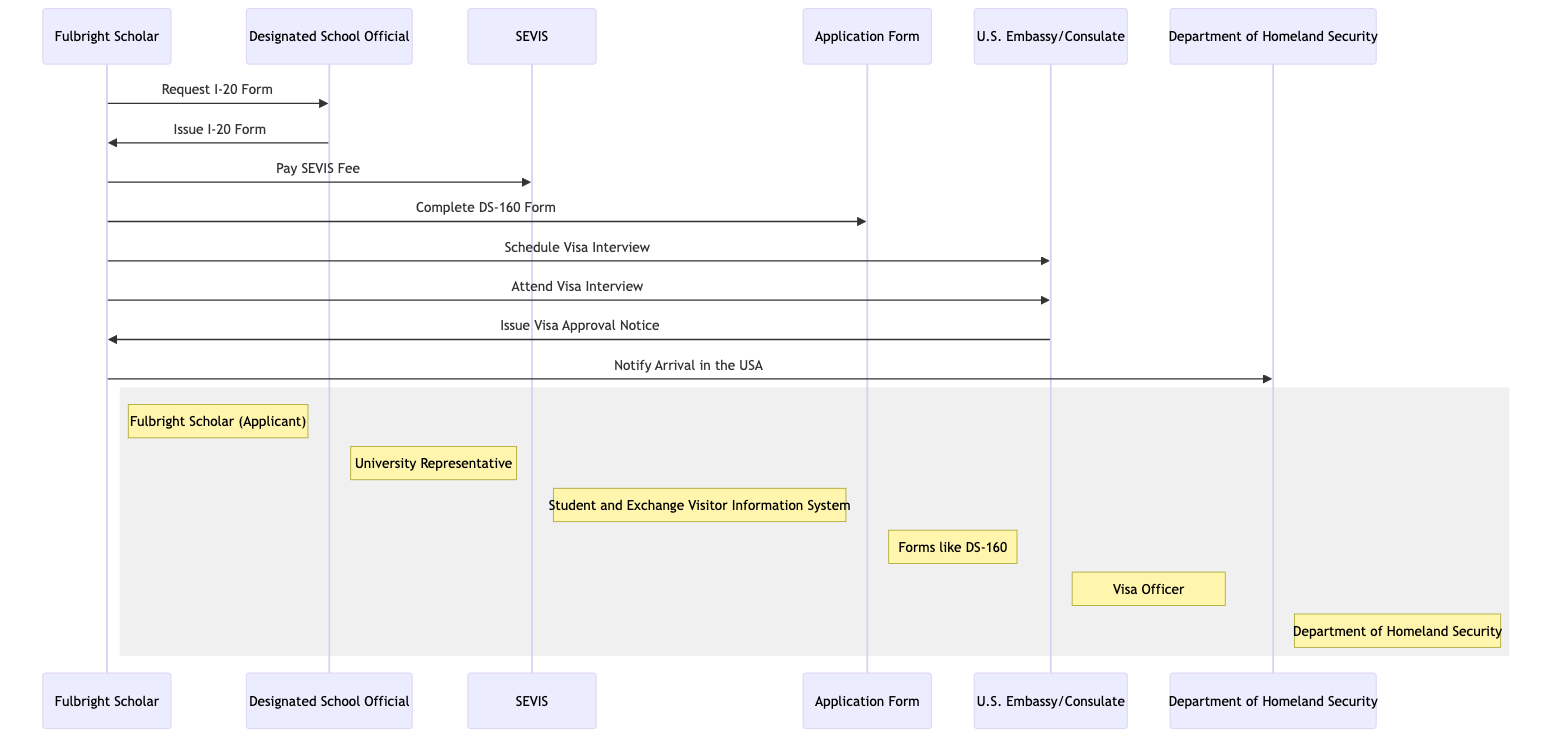What role does the Designated School Official play? The Designated School Official (DSO) is categorized as a University Representative in the diagram, indicating their responsibility for assisting the Fulbright Scholar during the application process as an authorized person at the educational institution.
Answer: University Representative How many messages are exchanged in the diagram? By counting the arrows representing the messages between actors in the sequence diagram, there are a total of 8 messages exchanged, indicating the various steps the Fulbright Scholar undertakes in the visa application process.
Answer: 8 Who issues the Visa Approval Notice? The U.S. Embassy/Consulate is the entity that issues the Visa Approval Notice to the Fulbright Scholar after the visa interview, as indicated by the arrow direction and interaction shown in the diagram.
Answer: U.S. Embassy/Consulate What document must the Fulbright Scholar complete as part of the application process? The Fulbright Scholar has to complete the DS-160 Form, which is represented as an Application Form in the diagram, indicating it is a crucial document for the visa application.
Answer: DS-160 Form What action does the Fulbright Scholar take after paying the SEVIS Fee? After paying the SEVIS Fee, the Fulbright Scholar schedules a Visa Interview, following the sequence of actions laid out in the diagram, which showcases the ordered steps in the visa application process.
Answer: Schedule Visa Interview Which party is notified about the Fulbright Scholar's arrival in the USA? The Department of Homeland Security (DHS) is notified about the Fulbright Scholar's arrival in the USA, as indicated by the diagram showing the interaction at the end of the process.
Answer: Department of Homeland Security What is the purpose of the I-20 Form in the process? The I-20 Form, or Certificate of Eligibility for Nonimmigrant Student Status, is essential for the Fulbright Scholar to legally apply for a student visa, reflecting its critical function in the sequence of actions depicted in the diagram.
Answer: Certificate of Eligibility for Nonimmigrant Student Status What is the sequence of actions starting from requesting the I-20 Form to notifying DHS? The sequence of actions begins with the Fulbright Scholar requesting the I-20 Form from the DSO, receiving it, paying the SEVIS Fee, completing the DS-160 Form, scheduling and attending the visa interview, receiving the Visa Approval Notice, and finally notifying the Department of Homeland Security about their arrival in the US. This flow illustrates the structured process one must follow in the visa application journey.
Answer: Request I-20 Form to Notify Arrival in the USA 